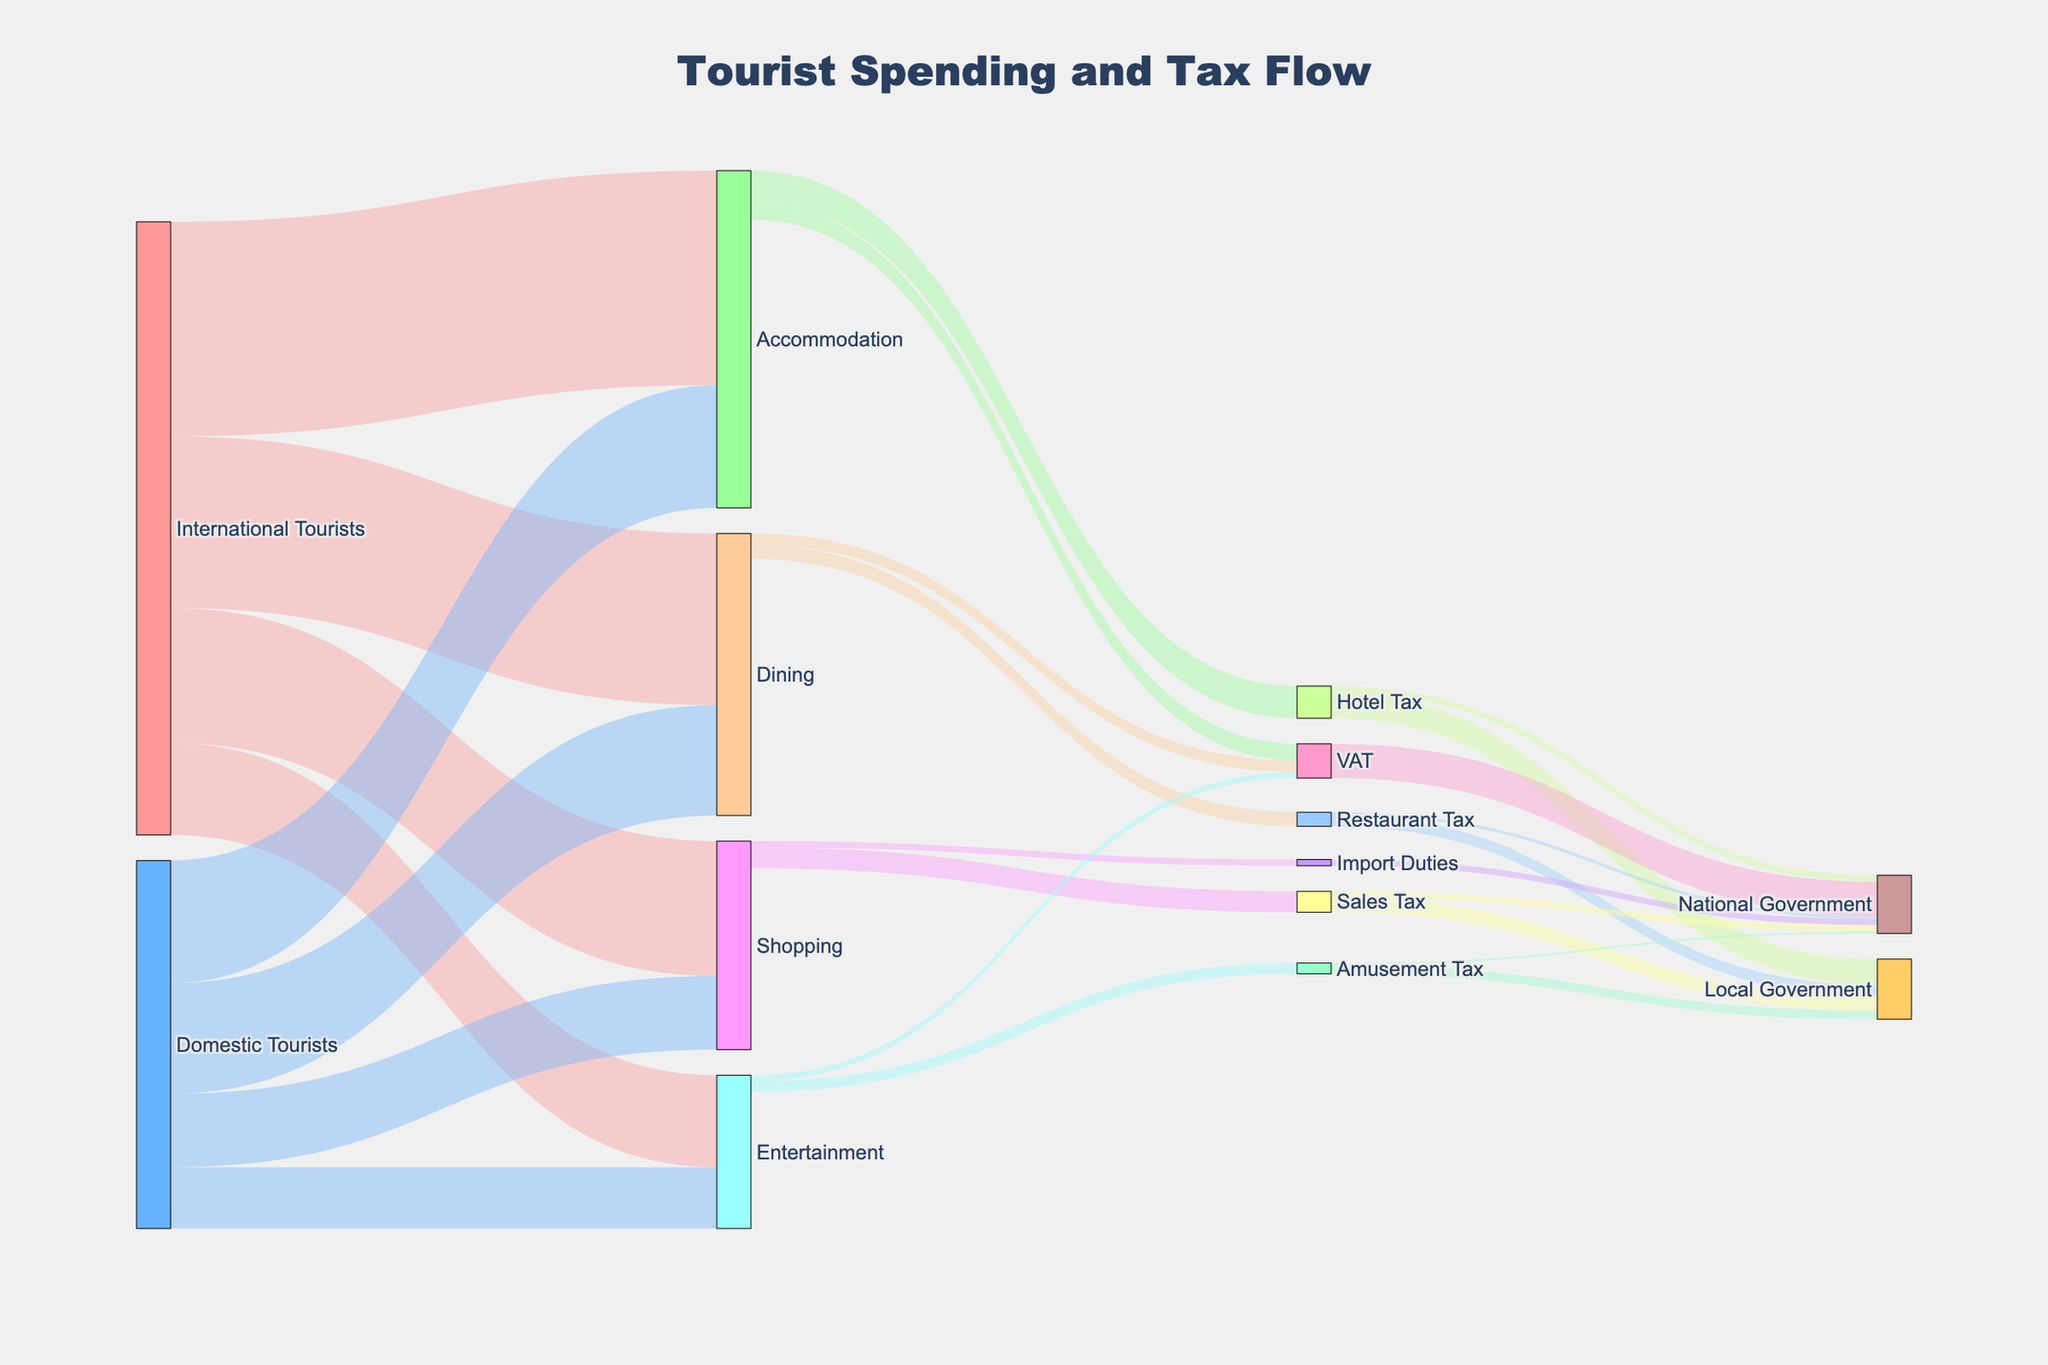Which category receives the most spending from international tourists? By looking at the Sankey flow, we see that 'Accommodation' has the highest value (3500) among international tourists.
Answer: Accommodation What is the total spending by domestic tourists? Summing the values for domestic tourists: Accommodation (2000) + Dining (1800) + Shopping (1200) + Entertainment (1000) results in 6000.
Answer: 6000 How much VAT is collected from tourist activities? Adding VAT values from Accommodation (275), Dining (184), and Entertainment (100), the total VAT is 559.
Answer: 559 Which tax category contributes the most to the local government? Comparing contributions: Hotel Tax (420), Restaurant Tax (184), Sales Tax (238), Amusement Tax (140). The highest is from Hotel Tax (420).
Answer: Hotel Tax How does spending on Dining by international tourists compare to domestic tourists? International tourists spend 2800 on Dining, while domestic tourists spend 1800. International tourists spend 1000 more.
Answer: International tourists spend 1000 more What is the total revenue generated for the national government from all taxes? Summing contributions: Hotel Tax (105), Restaurant Tax (46), Sales Tax (102), Amusement Tax (35), VAT (559), Import Duties (102) results in a total of 949.
Answer: 949 What is the total spending on Shopping by both international and domestic tourists? Summing the values for Shopping: International (2200) + Domestic (1200) equals 3400.
Answer: 3400 What percentage of the total Accommodation spending is taxed as Hotel Tax? Total Accommodation spending is 5500 (3500 international + 2000 domestic). Hotel Tax collected is 525, so percentage = (525/5500) * 100 ≈ 9.55%.
Answer: 9.55% How does the revenue from VAT on Dining compare to the revenue from Restaurant Tax? VAT on Dining is 184 and Restaurant Tax is 230. Restaurant Tax generates 46 more than VAT on Dining.
Answer: Restaurant Tax generates 46 more 